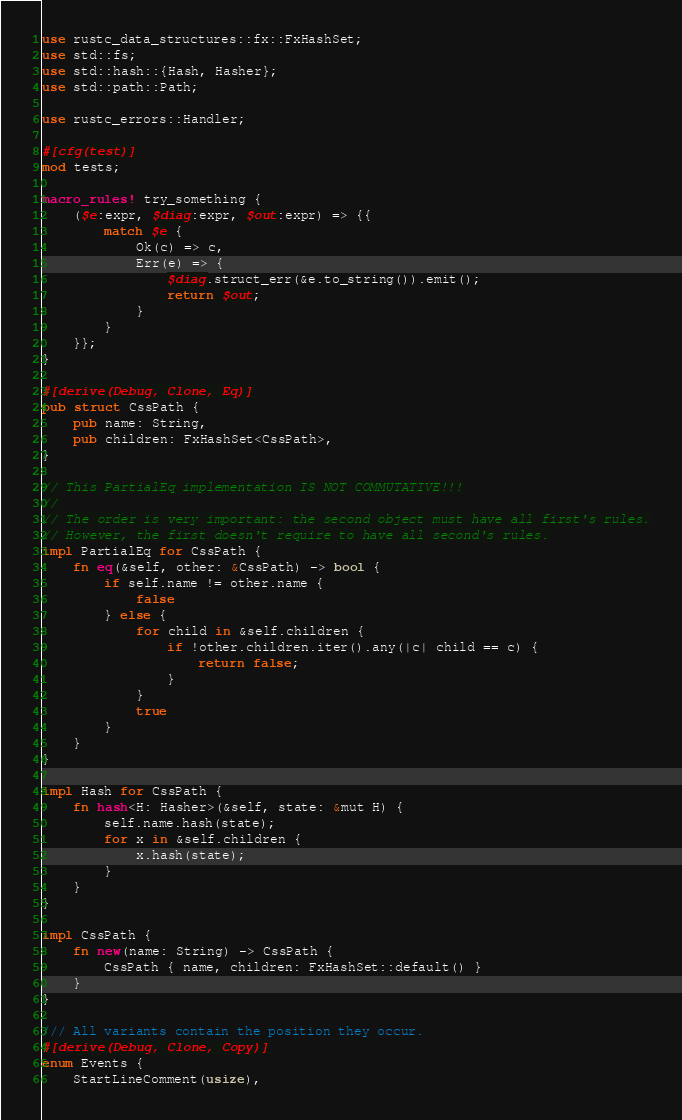<code> <loc_0><loc_0><loc_500><loc_500><_Rust_>use rustc_data_structures::fx::FxHashSet;
use std::fs;
use std::hash::{Hash, Hasher};
use std::path::Path;

use rustc_errors::Handler;

#[cfg(test)]
mod tests;

macro_rules! try_something {
    ($e:expr, $diag:expr, $out:expr) => {{
        match $e {
            Ok(c) => c,
            Err(e) => {
                $diag.struct_err(&e.to_string()).emit();
                return $out;
            }
        }
    }};
}

#[derive(Debug, Clone, Eq)]
pub struct CssPath {
    pub name: String,
    pub children: FxHashSet<CssPath>,
}

// This PartialEq implementation IS NOT COMMUTATIVE!!!
//
// The order is very important: the second object must have all first's rules.
// However, the first doesn't require to have all second's rules.
impl PartialEq for CssPath {
    fn eq(&self, other: &CssPath) -> bool {
        if self.name != other.name {
            false
        } else {
            for child in &self.children {
                if !other.children.iter().any(|c| child == c) {
                    return false;
                }
            }
            true
        }
    }
}

impl Hash for CssPath {
    fn hash<H: Hasher>(&self, state: &mut H) {
        self.name.hash(state);
        for x in &self.children {
            x.hash(state);
        }
    }
}

impl CssPath {
    fn new(name: String) -> CssPath {
        CssPath { name, children: FxHashSet::default() }
    }
}

/// All variants contain the position they occur.
#[derive(Debug, Clone, Copy)]
enum Events {
    StartLineComment(usize),</code> 